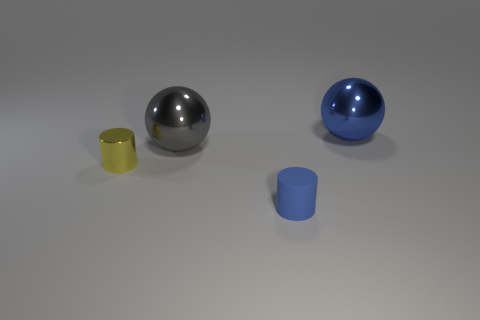What number of other things are there of the same size as the yellow cylinder?
Provide a short and direct response. 1. Is the color of the metallic cylinder the same as the tiny cylinder to the right of the gray shiny ball?
Your response must be concise. No. How many balls are metal things or tiny objects?
Your answer should be compact. 2. Are there any other things that are the same color as the tiny shiny cylinder?
Make the answer very short. No. What material is the large sphere left of the large sphere right of the tiny blue matte cylinder made of?
Your answer should be very brief. Metal. Do the big gray thing and the blue thing that is behind the tiny yellow metal cylinder have the same material?
Keep it short and to the point. Yes. How many objects are either big spheres that are behind the gray metal ball or big blue rubber things?
Your answer should be compact. 1. Is there another small thing that has the same color as the small shiny object?
Keep it short and to the point. No. There is a large gray object; is it the same shape as the blue object that is behind the yellow thing?
Offer a very short reply. Yes. How many blue things are behind the tiny yellow cylinder and in front of the metal cylinder?
Your answer should be compact. 0. 